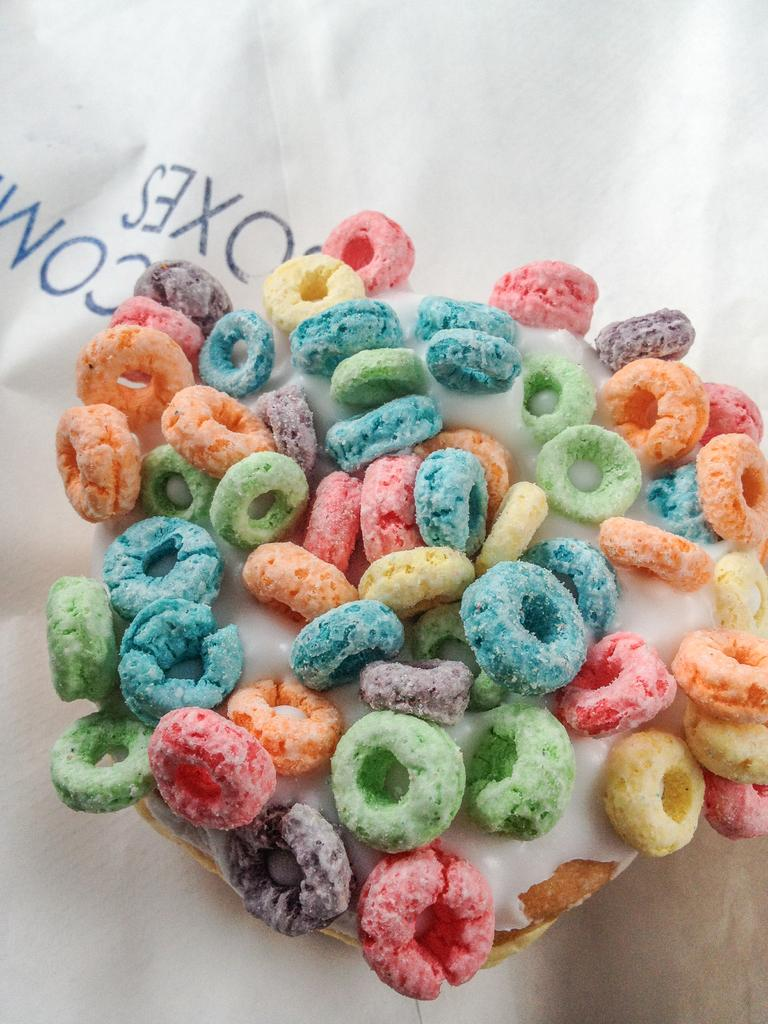What is the main subject of the image? There is a white object in the image. What can be seen on the white object? The white object has colorful things on it. Where is the text located in the image? The text is on the left side of the image. Can you hear the horn in the image? There is no horn present in the image, so it cannot be heard. 